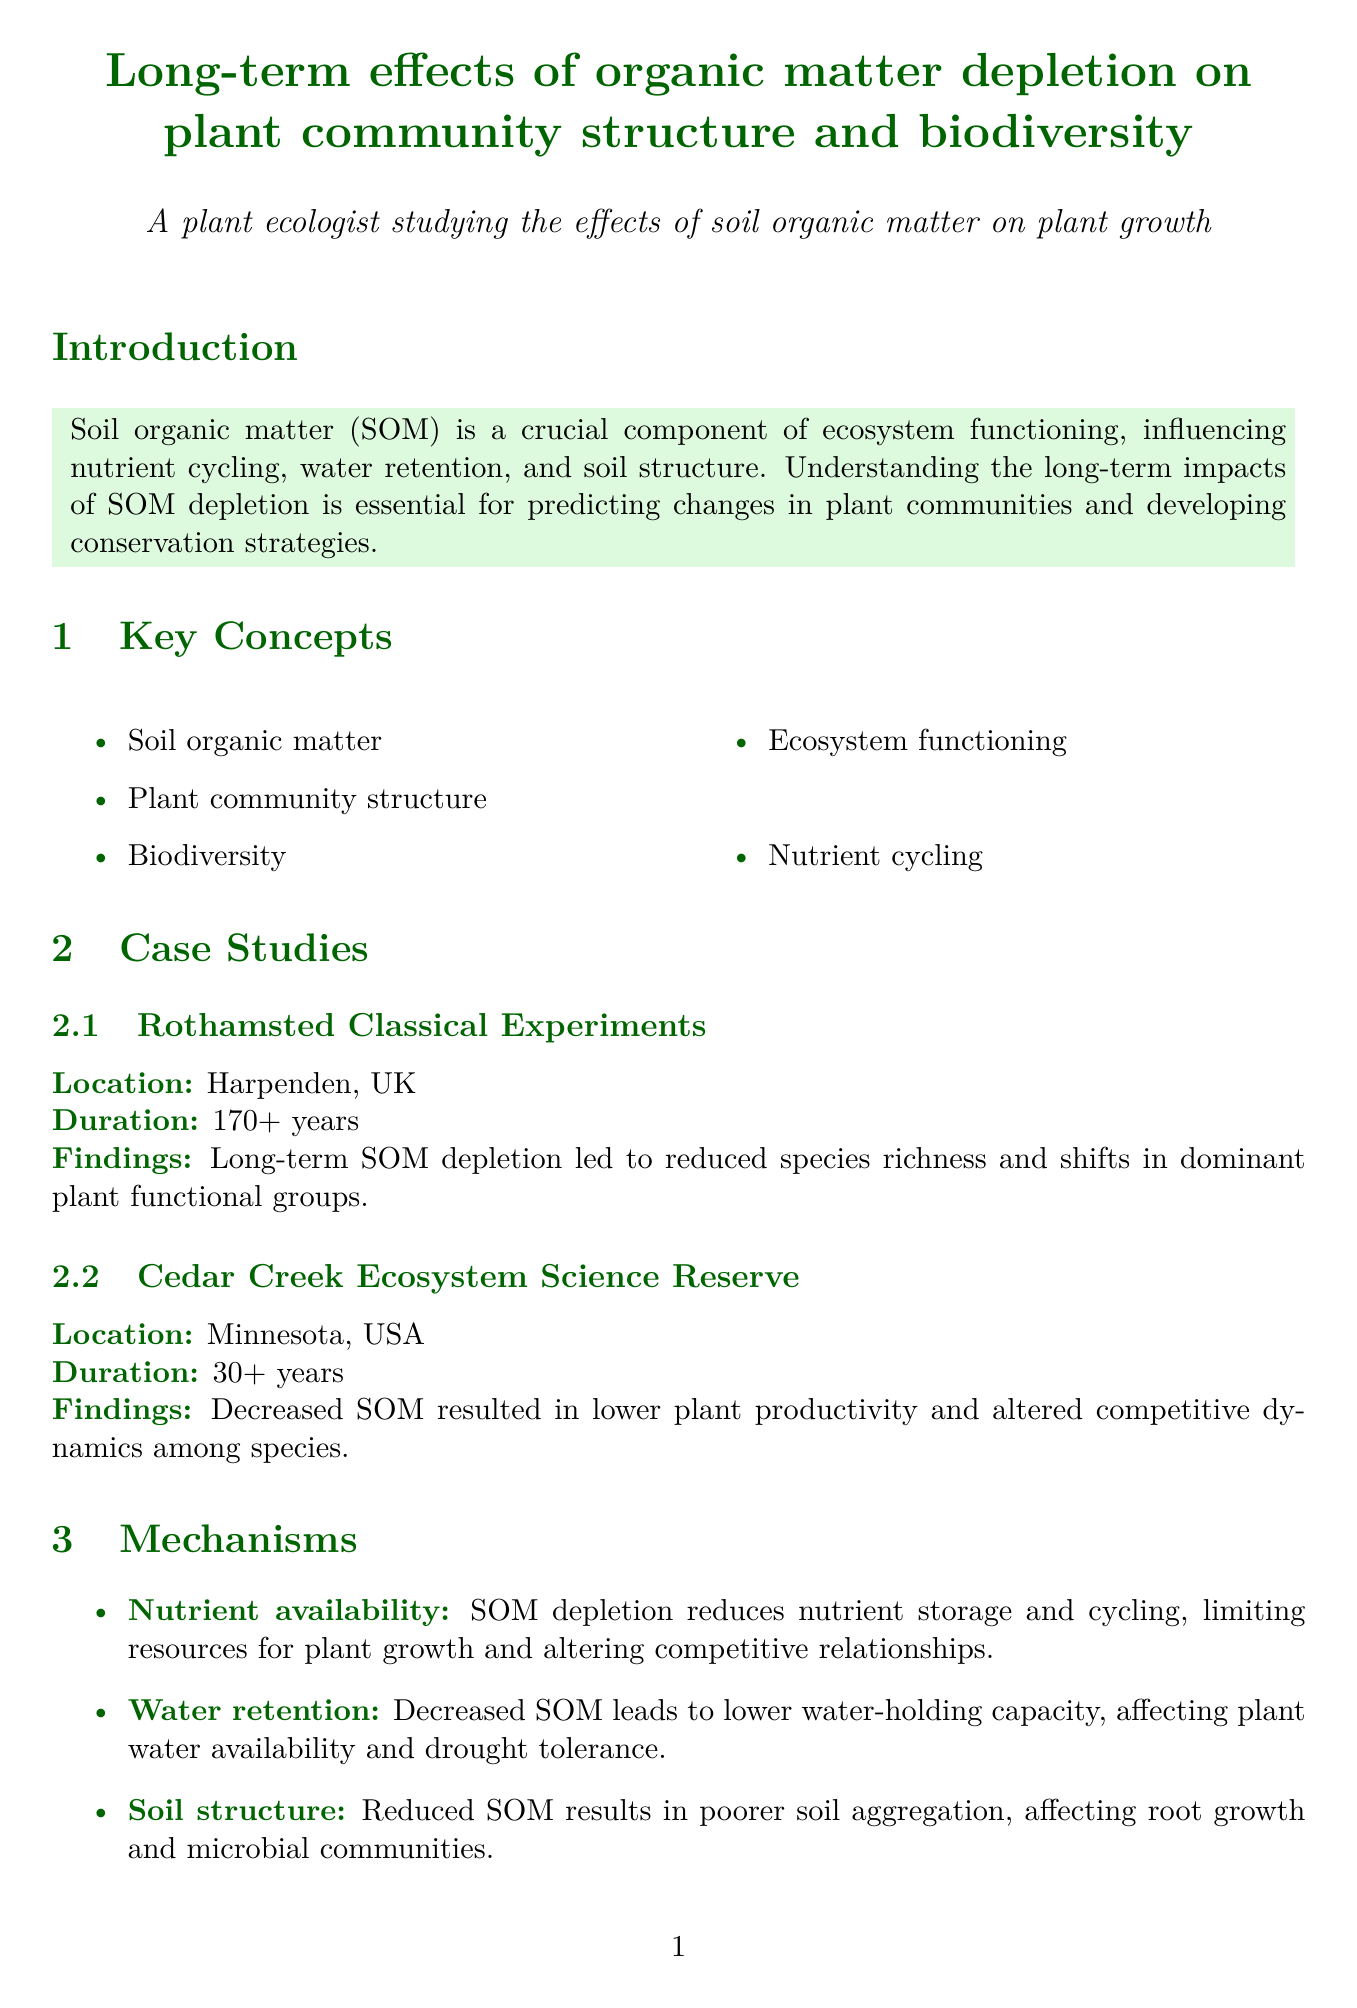What is the title of the report? The title of the report is presented at the top, under the author's name.
Answer: Long-term effects of organic matter depletion on plant community structure and biodiversity How long did the Rothamsted Classical Experiments last? The duration of the Rothamsted Classical Experiments is mentioned in the case studies section of the document.
Answer: 170+ years What is one of the findings from the Cedar Creek Ecosystem Science Reserve? The findings from the Cedar Creek Ecosystem Science Reserve are outlined in the case studies section.
Answer: Decreased SOM resulted in lower plant productivity and altered competitive dynamics among species What mechanism does SOM depletion affect regarding nutrient availability? This question refers to the mechanisms section, which discusses how SOM impacts nutrient storage and cycling.
Answer: Limits resources for plant growth What impact does SOM depletion have on alpha diversity? The impact on alpha diversity is mentioned in the biodiversity effects section.
Answer: Decreased species richness within local communities Which management strategy minimizes soil disturbance? The management implications section discusses various strategies, specifying their benefits.
Answer: Conservation tillage What is a future research direction mentioned in the report? Future research directions are listed at the end of the document, focusing on potential areas for study.
Answer: Long-term experiments in diverse ecosystems to capture global variation in SOM depletion effects What level of biodiversity is impacted by the homogenization of plant communities? This concept is explained under the biodiversity effects section.
Answer: Beta diversity 